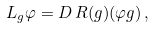Convert formula to latex. <formula><loc_0><loc_0><loc_500><loc_500>L _ { g } \varphi = D \, R ( g ) ( \varphi g ) \, ,</formula> 